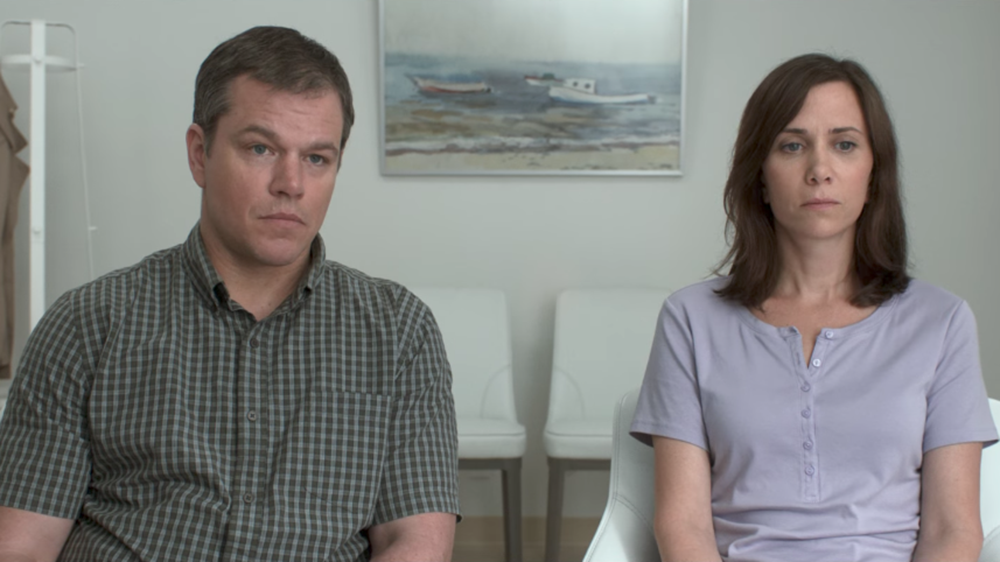What story could this image tell? This image could be telling the story of two individuals preparing for a life-changing event. They may be participants in a clinical trial, sitting in a waiting room before receiving significant information. Their serious and reflective expressions suggest they are mentally bracing themselves for what is to come. The boat painting could metaphorically represent their upcoming journey, navigating through uncharted waters and facing unknown challenges together. Describe a realistic scenario where these people are waiting for important news. A realistic scenario might be that these individuals are waiting for medical test results. Perhaps they are a couple, and one of them has undergone significant health screenings. The quiet, minimalist setting of the room highlights the seriousness of the moment, as they prepare to receive news that could potentially change their lives. Their expressions of quiet contemplation hint at the anxiety and hope they are sharing in those tense minutes. 